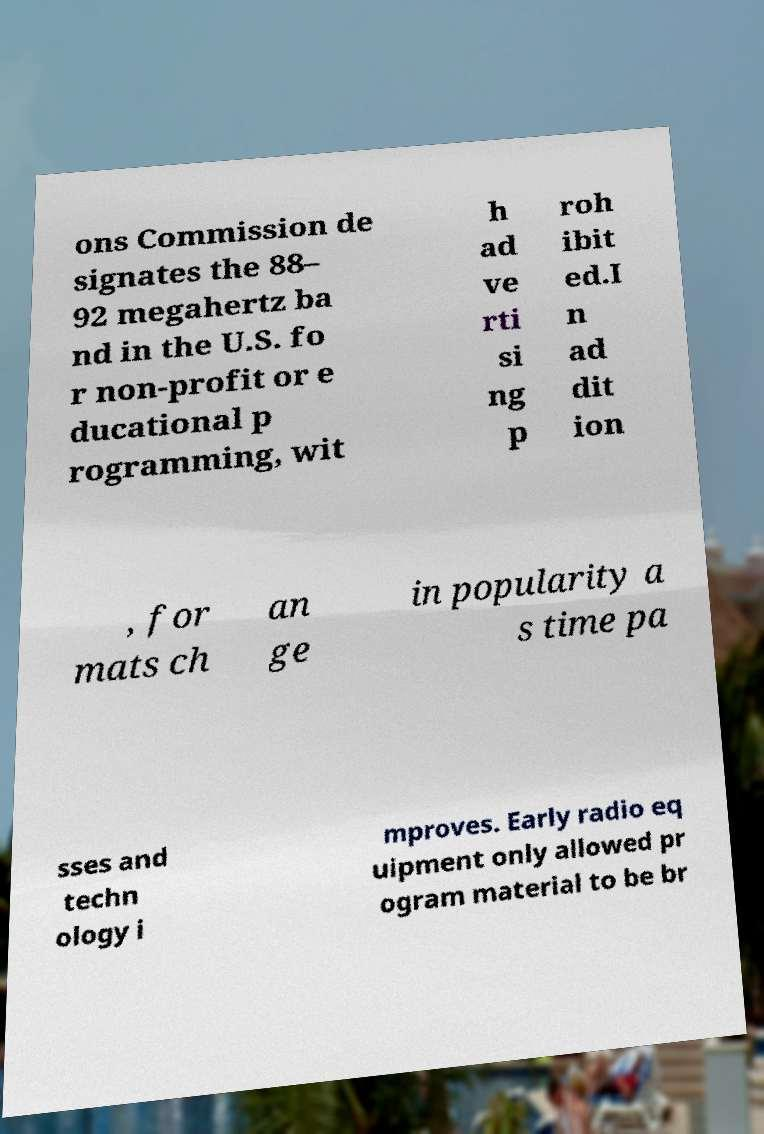Could you assist in decoding the text presented in this image and type it out clearly? ons Commission de signates the 88– 92 megahertz ba nd in the U.S. fo r non-profit or e ducational p rogramming, wit h ad ve rti si ng p roh ibit ed.I n ad dit ion , for mats ch an ge in popularity a s time pa sses and techn ology i mproves. Early radio eq uipment only allowed pr ogram material to be br 